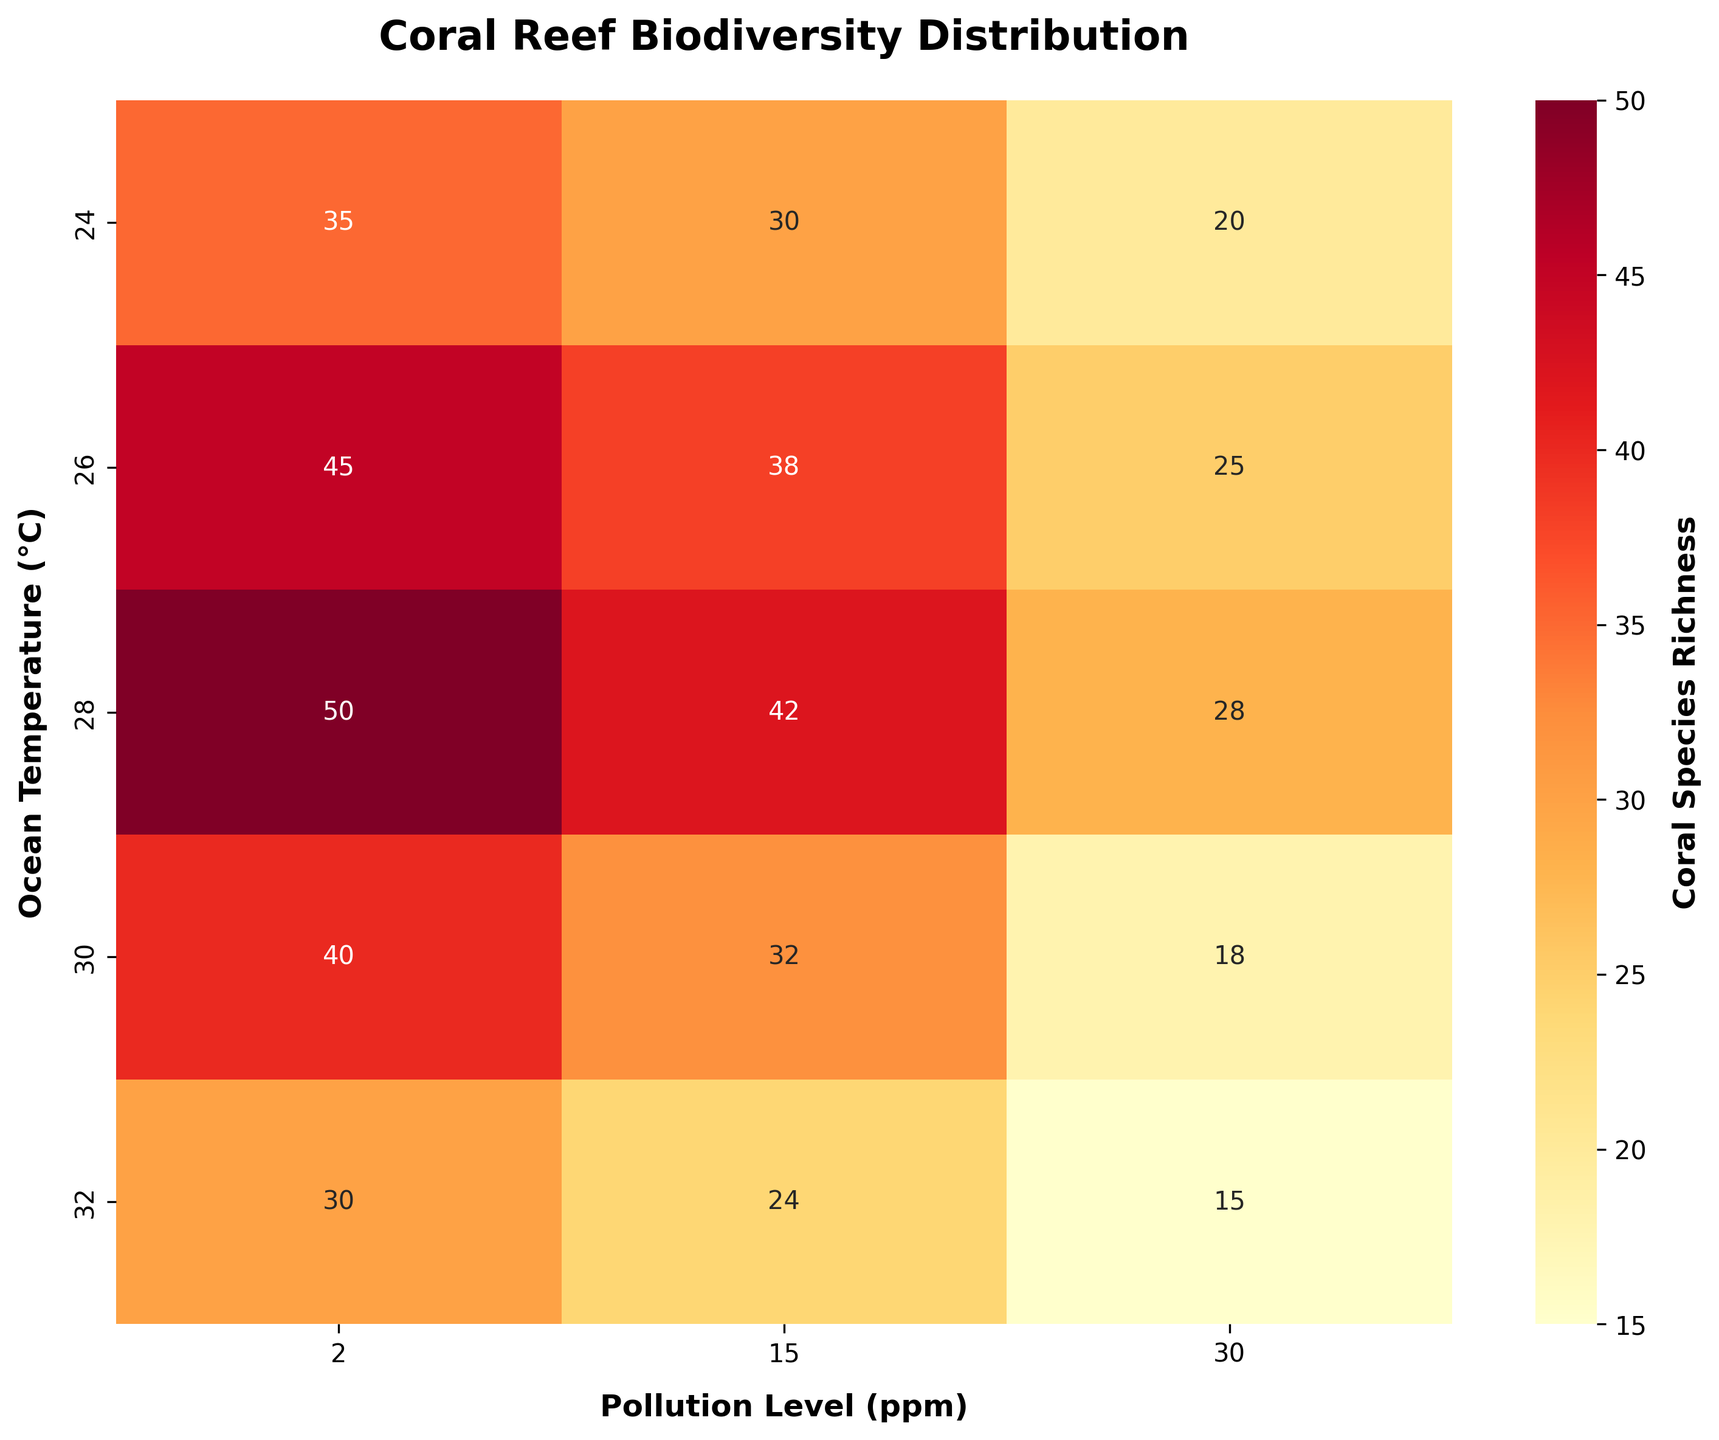What is the title of the figure? The title of the figure is located at the top of the plot and summarizes what the plot is about. The title is often bold and has a larger font size.
Answer: Coral Reef Biodiversity Distribution Which ocean temperature and pollution level combination has the highest coral species richness? Locate the cell with the highest value in the heatmap. Note the corresponding ocean temperature (y-axis) and pollution level (x-axis) for this cell.
Answer: 28°C and 2 ppm How does coral species richness change as pollution level increases for an ocean temperature of 26°C? Identify the row corresponding to 26°C. Examine the three values in this row and observe the trend as the pollution level increases from 2 ppm to 30 ppm.
Answer: It decreases from 45 to 25 At what pollution level do we observe the lowest coral species richness? Find the column with the overall lowest value in the heatmap. The corresponding pollution level on the x-axis indicates where the lowest coral species richness occurs.
Answer: 30 ppm On average, how does coral species richness compare between ocean temperatures of 24°C and 30°C at a pollution level of 15 ppm? Locate the values for 24°C and 30°C at 15 ppm. Calculate the average richness for each temperature and compare them.
Answer: 30°C is less by an average of 32 Which ocean temperature has a lower species richness at the pollution level of 15 ppm, 24°C or 32°C? Find the cells corresponding to 15 ppm and ocean temperatures of 24°C and 32°C. Compare their values.
Answer: 32°C has lower richness What general trend can you observe in coral species richness as ocean temperature increases while keeping pollution levels constant? Examine the heatmap rows and observe how the values change as you move from left to right (i.e., as temperature increases) for each pollution level.
Answer: It generally decreases For an ocean temperature of 28°C, what is the difference in coral species richness between pollution levels of 2 ppm and 30 ppm? Find the values for 28°C at 2 ppm and 30 ppm. Subtract the smaller value from the larger value to get the difference.
Answer: 22 How does the overall color intensity relate to coral species richness on this heatmap? Review the color gradient used in the heatmap. Identify which colors represent higher and lower coral species richness and explain the relationship.
Answer: Warmer colors represent higher richness What is the average coral species richness across all pollution levels at 30°C? Identify the values at 30°C for all pollution levels. Sum these values and divide by the number of pollution levels (3) to find the average.
Answer: 30 रस – Matzella नोट्स: 